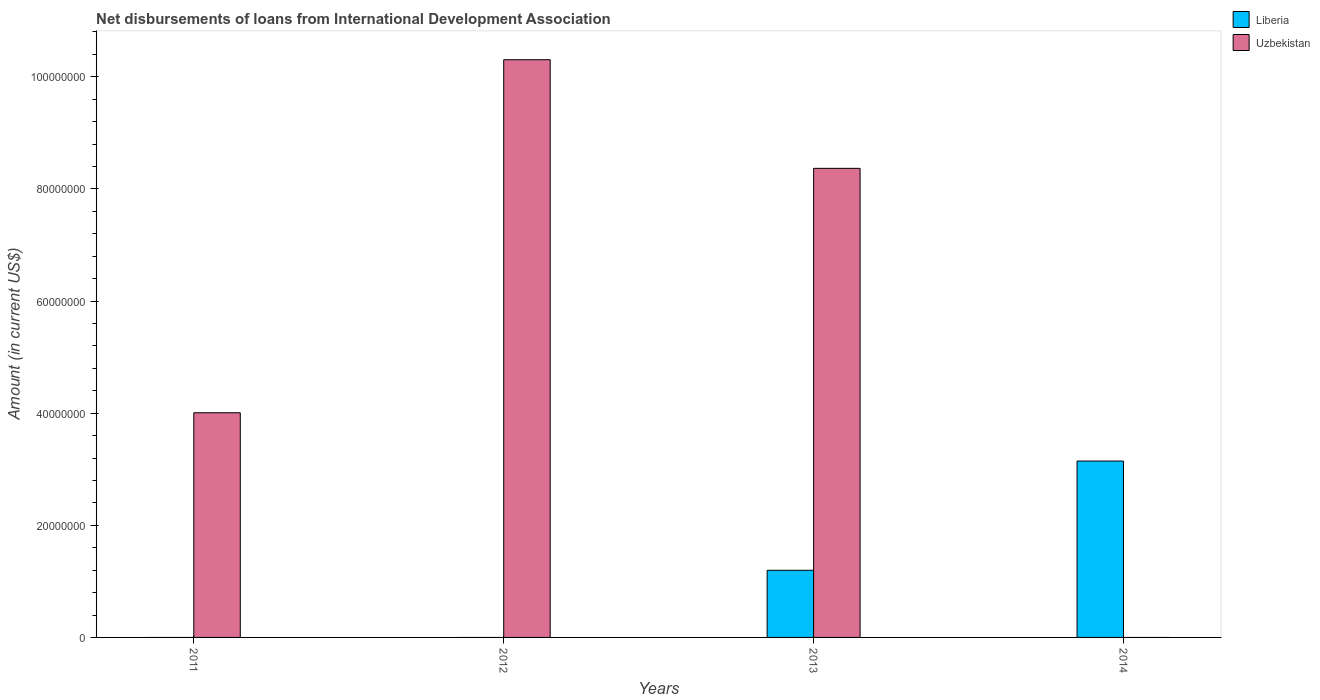How many different coloured bars are there?
Your answer should be very brief. 2. Are the number of bars per tick equal to the number of legend labels?
Your answer should be compact. No. Are the number of bars on each tick of the X-axis equal?
Offer a very short reply. No. How many bars are there on the 1st tick from the right?
Give a very brief answer. 1. In how many cases, is the number of bars for a given year not equal to the number of legend labels?
Offer a very short reply. 3. What is the amount of loans disbursed in Uzbekistan in 2012?
Provide a short and direct response. 1.03e+08. Across all years, what is the maximum amount of loans disbursed in Liberia?
Offer a very short reply. 3.15e+07. What is the total amount of loans disbursed in Uzbekistan in the graph?
Keep it short and to the point. 2.27e+08. What is the difference between the amount of loans disbursed in Uzbekistan in 2011 and that in 2012?
Give a very brief answer. -6.30e+07. What is the difference between the amount of loans disbursed in Uzbekistan in 2014 and the amount of loans disbursed in Liberia in 2012?
Make the answer very short. 0. What is the average amount of loans disbursed in Uzbekistan per year?
Your answer should be compact. 5.67e+07. In the year 2013, what is the difference between the amount of loans disbursed in Liberia and amount of loans disbursed in Uzbekistan?
Keep it short and to the point. -7.17e+07. In how many years, is the amount of loans disbursed in Liberia greater than 16000000 US$?
Keep it short and to the point. 1. What is the ratio of the amount of loans disbursed in Liberia in 2013 to that in 2014?
Offer a terse response. 0.38. What is the difference between the highest and the second highest amount of loans disbursed in Uzbekistan?
Offer a terse response. 1.94e+07. What is the difference between the highest and the lowest amount of loans disbursed in Liberia?
Provide a succinct answer. 3.15e+07. Are all the bars in the graph horizontal?
Provide a succinct answer. No. How many years are there in the graph?
Offer a very short reply. 4. Are the values on the major ticks of Y-axis written in scientific E-notation?
Provide a succinct answer. No. Does the graph contain any zero values?
Keep it short and to the point. Yes. Where does the legend appear in the graph?
Offer a very short reply. Top right. How many legend labels are there?
Provide a succinct answer. 2. What is the title of the graph?
Your response must be concise. Net disbursements of loans from International Development Association. What is the Amount (in current US$) of Uzbekistan in 2011?
Your response must be concise. 4.01e+07. What is the Amount (in current US$) in Uzbekistan in 2012?
Your answer should be very brief. 1.03e+08. What is the Amount (in current US$) in Liberia in 2013?
Ensure brevity in your answer.  1.20e+07. What is the Amount (in current US$) in Uzbekistan in 2013?
Keep it short and to the point. 8.37e+07. What is the Amount (in current US$) in Liberia in 2014?
Provide a succinct answer. 3.15e+07. What is the Amount (in current US$) in Uzbekistan in 2014?
Make the answer very short. 0. Across all years, what is the maximum Amount (in current US$) in Liberia?
Offer a terse response. 3.15e+07. Across all years, what is the maximum Amount (in current US$) of Uzbekistan?
Offer a terse response. 1.03e+08. Across all years, what is the minimum Amount (in current US$) in Uzbekistan?
Your answer should be very brief. 0. What is the total Amount (in current US$) in Liberia in the graph?
Offer a very short reply. 4.34e+07. What is the total Amount (in current US$) of Uzbekistan in the graph?
Your answer should be compact. 2.27e+08. What is the difference between the Amount (in current US$) of Uzbekistan in 2011 and that in 2012?
Provide a succinct answer. -6.30e+07. What is the difference between the Amount (in current US$) in Uzbekistan in 2011 and that in 2013?
Your answer should be compact. -4.36e+07. What is the difference between the Amount (in current US$) in Uzbekistan in 2012 and that in 2013?
Provide a short and direct response. 1.94e+07. What is the difference between the Amount (in current US$) of Liberia in 2013 and that in 2014?
Ensure brevity in your answer.  -1.95e+07. What is the average Amount (in current US$) of Liberia per year?
Offer a very short reply. 1.09e+07. What is the average Amount (in current US$) of Uzbekistan per year?
Make the answer very short. 5.67e+07. In the year 2013, what is the difference between the Amount (in current US$) in Liberia and Amount (in current US$) in Uzbekistan?
Make the answer very short. -7.17e+07. What is the ratio of the Amount (in current US$) of Uzbekistan in 2011 to that in 2012?
Offer a very short reply. 0.39. What is the ratio of the Amount (in current US$) of Uzbekistan in 2011 to that in 2013?
Your answer should be very brief. 0.48. What is the ratio of the Amount (in current US$) of Uzbekistan in 2012 to that in 2013?
Provide a short and direct response. 1.23. What is the ratio of the Amount (in current US$) in Liberia in 2013 to that in 2014?
Your answer should be very brief. 0.38. What is the difference between the highest and the second highest Amount (in current US$) in Uzbekistan?
Make the answer very short. 1.94e+07. What is the difference between the highest and the lowest Amount (in current US$) of Liberia?
Ensure brevity in your answer.  3.15e+07. What is the difference between the highest and the lowest Amount (in current US$) in Uzbekistan?
Offer a terse response. 1.03e+08. 